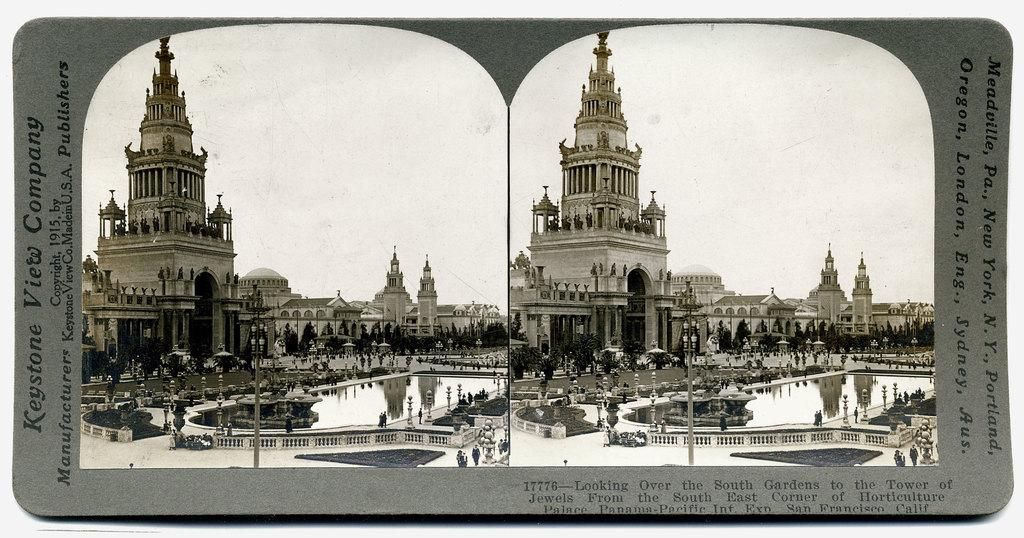What type of structures can be seen in the image? There are buildings in the image. What else is present in the image besides buildings? There is text, trees, poles, persons, water, grass, lights, fencing, ground, and sky visible in the image. What type of bean is being heated by friction in the image? There is no bean or indication of heat or friction present in the image. 